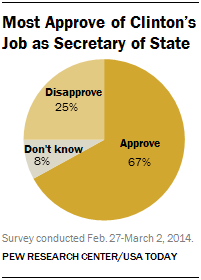What's the color of largest segment? The largest segment in the pie chart is colored in a shade of yellow, representing the portion of respondents who 'Approve' of the job performance in the context described in the chart. 